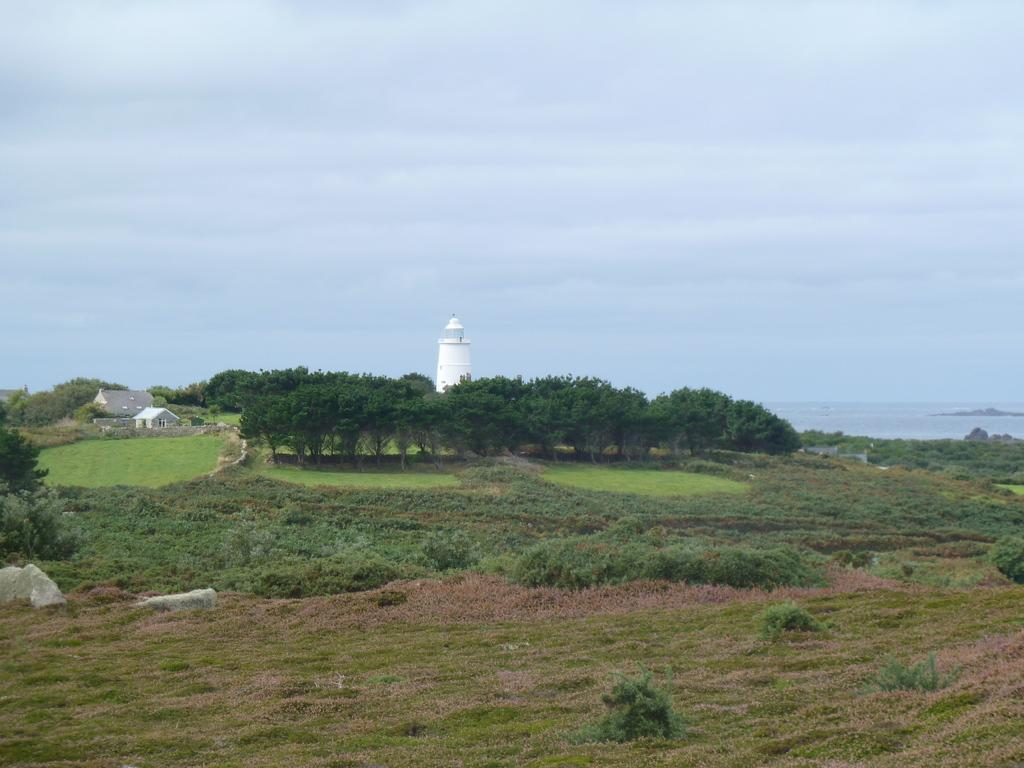What can be seen in the background of the image? In the background of the image, there is a sky, a tower, and houses. What type of vegetation is present in the image? There are trees, plants, and grass in the image. What other natural elements can be seen in the image? There are rocks in the image. What type of suit is the kettle wearing in the image? There is no kettle present in the image, and therefore no suit can be associated with it. 